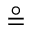Convert formula to latex. <formula><loc_0><loc_0><loc_500><loc_500>\circ e q</formula> 